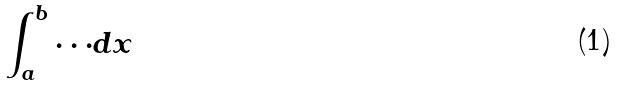<formula> <loc_0><loc_0><loc_500><loc_500>\int _ { a } ^ { b } \cdot \cdot \cdot d x</formula> 